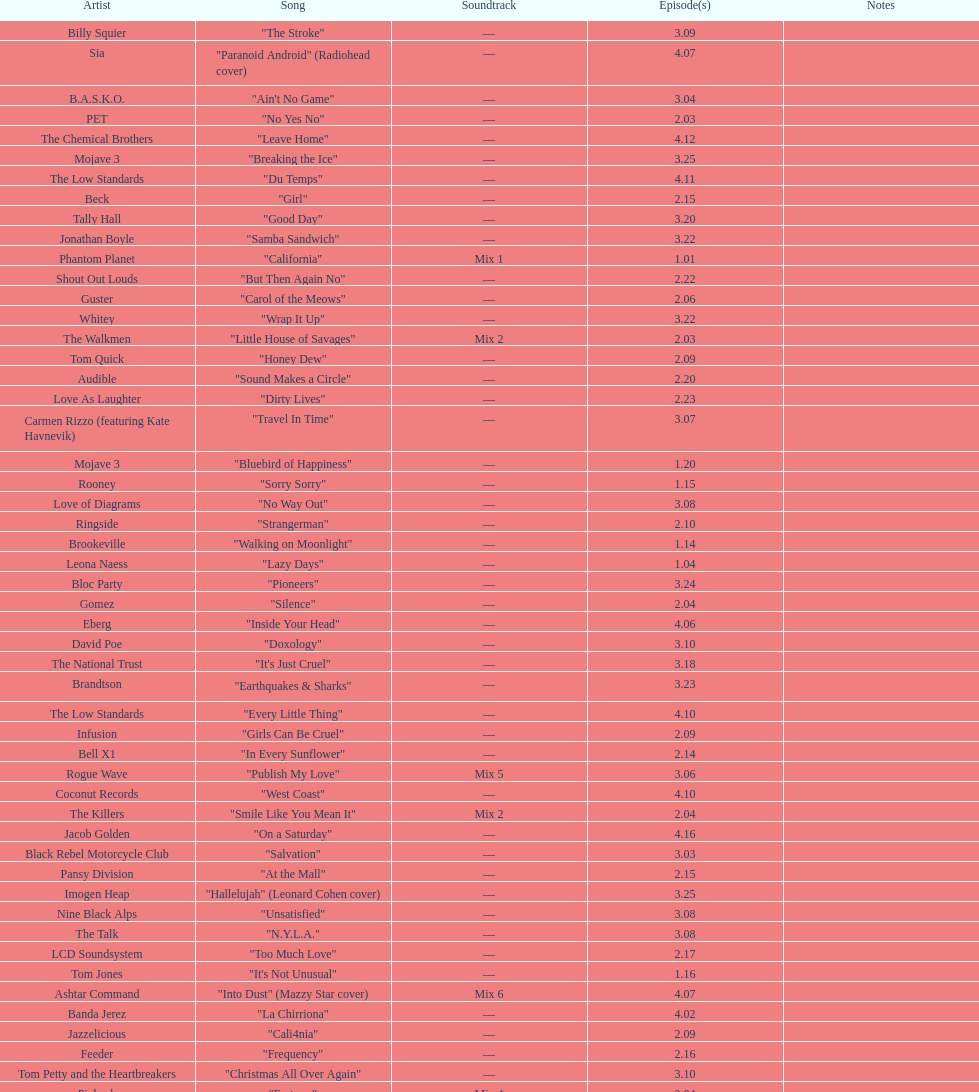The artist ash only had one song that appeared in the o.c. what is the name of that song? "Burn Baby Burn". 